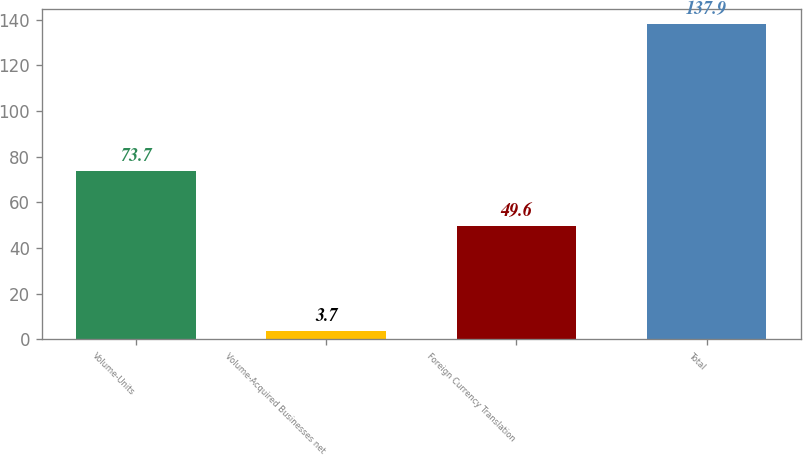<chart> <loc_0><loc_0><loc_500><loc_500><bar_chart><fcel>Volume-Units<fcel>Volume-Acquired Businesses net<fcel>Foreign Currency Translation<fcel>Total<nl><fcel>73.7<fcel>3.7<fcel>49.6<fcel>137.9<nl></chart> 